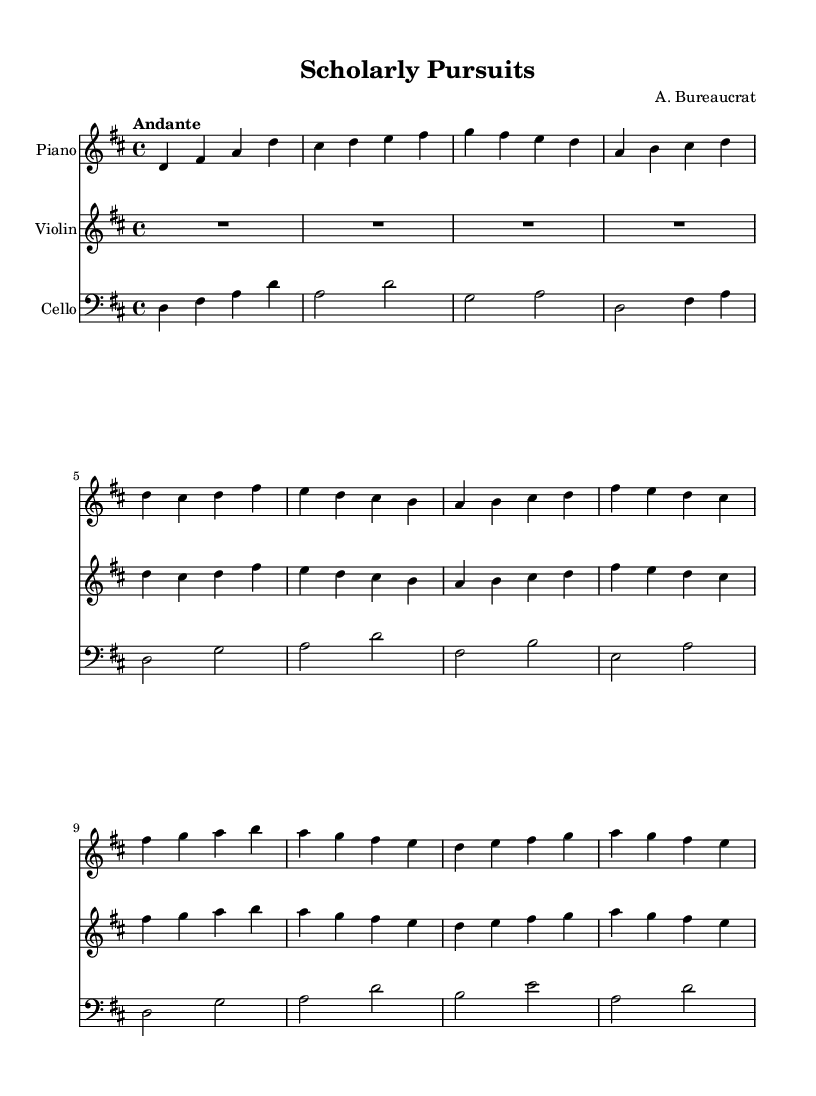What is the key signature of this music? The key signature is D major, which has two sharps (F# and C#). This can be identified by looking at the key signature indicated at the beginning of the staff.
Answer: D major What is the time signature of this piece? The time signature is 4/4, which means there are four beats in each measure, and a quarter note receives one beat. This can be determined by the symbol shown at the beginning of the music staff.
Answer: 4/4 What is the tempo marking given for this composition? The tempo marking is "Andante," which indicates a moderately slow tempo. The tempo indication is generally found at the beginning of the score, usually above the staff.
Answer: Andante Which instrument plays the melody predominantly? The melody is predominantly played by the violin, as it has the highest pitch and carries the musical line. This is inferred from the layout of the score where the violin part is positioned above the piano and cello parts.
Answer: Violin How many measures are in the piano part? There are 8 measures in the piano part, as counted by the number of vertical lines separating each measure in the score. Each group of notes between two bar lines represents one measure.
Answer: 8 What is the last note played by the cello? The last note played by the cello is D, which can be identified by looking at the final measure of the cello staff where the note is represented.
Answer: D What is the relationship of the violin and piano parts in this composition? The violin and piano parts interact as the violin plays the main melodic line while the piano provides harmonic support, creating a dialogue between melody and accompaniment. This reflection can be observed by analyzing the parts in context, where the violin frequently plays higher notes and the piano complements those with chords.
Answer: Dialogue 